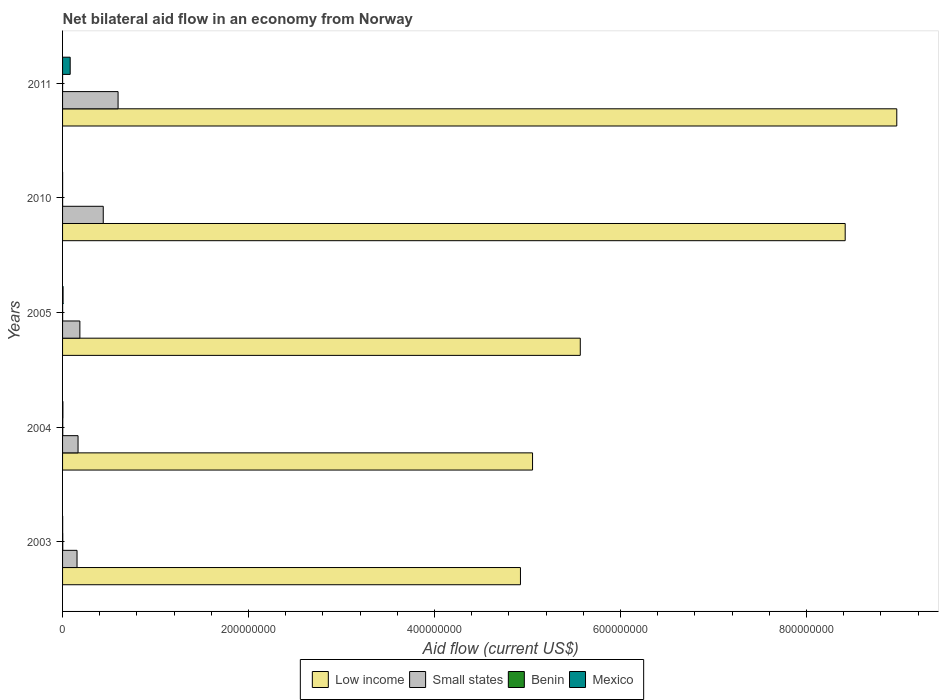Are the number of bars per tick equal to the number of legend labels?
Ensure brevity in your answer.  Yes. How many bars are there on the 3rd tick from the top?
Give a very brief answer. 4. How many bars are there on the 1st tick from the bottom?
Your answer should be very brief. 4. What is the label of the 3rd group of bars from the top?
Ensure brevity in your answer.  2005. In how many cases, is the number of bars for a given year not equal to the number of legend labels?
Offer a very short reply. 0. What is the net bilateral aid flow in Small states in 2003?
Make the answer very short. 1.56e+07. Across all years, what is the maximum net bilateral aid flow in Mexico?
Offer a terse response. 8.19e+06. Across all years, what is the minimum net bilateral aid flow in Mexico?
Offer a very short reply. 5.00e+04. What is the difference between the net bilateral aid flow in Small states in 2003 and that in 2004?
Offer a very short reply. -1.10e+06. What is the difference between the net bilateral aid flow in Low income in 2004 and the net bilateral aid flow in Benin in 2011?
Ensure brevity in your answer.  5.05e+08. What is the average net bilateral aid flow in Small states per year?
Offer a terse response. 3.09e+07. In the year 2010, what is the difference between the net bilateral aid flow in Low income and net bilateral aid flow in Mexico?
Keep it short and to the point. 8.42e+08. In how many years, is the net bilateral aid flow in Benin greater than 560000000 US$?
Offer a terse response. 0. Is the net bilateral aid flow in Mexico in 2003 less than that in 2010?
Keep it short and to the point. No. Is the difference between the net bilateral aid flow in Low income in 2003 and 2004 greater than the difference between the net bilateral aid flow in Mexico in 2003 and 2004?
Your answer should be very brief. No. What is the difference between the highest and the second highest net bilateral aid flow in Low income?
Offer a terse response. 5.55e+07. What is the difference between the highest and the lowest net bilateral aid flow in Mexico?
Give a very brief answer. 8.14e+06. What does the 2nd bar from the top in 2003 represents?
Give a very brief answer. Benin. What does the 3rd bar from the bottom in 2005 represents?
Your answer should be very brief. Benin. How many bars are there?
Make the answer very short. 20. What is the difference between two consecutive major ticks on the X-axis?
Make the answer very short. 2.00e+08. How many legend labels are there?
Provide a succinct answer. 4. How are the legend labels stacked?
Your answer should be compact. Horizontal. What is the title of the graph?
Give a very brief answer. Net bilateral aid flow in an economy from Norway. What is the Aid flow (current US$) in Low income in 2003?
Offer a terse response. 4.92e+08. What is the Aid flow (current US$) in Small states in 2003?
Your response must be concise. 1.56e+07. What is the Aid flow (current US$) of Low income in 2004?
Offer a terse response. 5.05e+08. What is the Aid flow (current US$) in Small states in 2004?
Your response must be concise. 1.66e+07. What is the Aid flow (current US$) in Mexico in 2004?
Ensure brevity in your answer.  3.60e+05. What is the Aid flow (current US$) in Low income in 2005?
Provide a short and direct response. 5.57e+08. What is the Aid flow (current US$) of Small states in 2005?
Give a very brief answer. 1.86e+07. What is the Aid flow (current US$) of Benin in 2005?
Provide a short and direct response. 6.00e+04. What is the Aid flow (current US$) in Mexico in 2005?
Ensure brevity in your answer.  5.30e+05. What is the Aid flow (current US$) of Low income in 2010?
Offer a very short reply. 8.42e+08. What is the Aid flow (current US$) of Small states in 2010?
Keep it short and to the point. 4.38e+07. What is the Aid flow (current US$) in Benin in 2010?
Your answer should be compact. 5.00e+04. What is the Aid flow (current US$) in Mexico in 2010?
Your answer should be compact. 5.00e+04. What is the Aid flow (current US$) in Low income in 2011?
Your answer should be very brief. 8.97e+08. What is the Aid flow (current US$) of Small states in 2011?
Your response must be concise. 5.97e+07. What is the Aid flow (current US$) of Mexico in 2011?
Provide a short and direct response. 8.19e+06. Across all years, what is the maximum Aid flow (current US$) in Low income?
Your response must be concise. 8.97e+08. Across all years, what is the maximum Aid flow (current US$) in Small states?
Make the answer very short. 5.97e+07. Across all years, what is the maximum Aid flow (current US$) of Benin?
Your answer should be compact. 2.20e+05. Across all years, what is the maximum Aid flow (current US$) of Mexico?
Provide a short and direct response. 8.19e+06. Across all years, what is the minimum Aid flow (current US$) of Low income?
Offer a very short reply. 4.92e+08. Across all years, what is the minimum Aid flow (current US$) in Small states?
Your response must be concise. 1.56e+07. Across all years, what is the minimum Aid flow (current US$) of Benin?
Offer a very short reply. 10000. What is the total Aid flow (current US$) of Low income in the graph?
Your response must be concise. 3.29e+09. What is the total Aid flow (current US$) in Small states in the graph?
Provide a short and direct response. 1.54e+08. What is the total Aid flow (current US$) in Benin in the graph?
Provide a succinct answer. 5.50e+05. What is the total Aid flow (current US$) in Mexico in the graph?
Keep it short and to the point. 9.22e+06. What is the difference between the Aid flow (current US$) of Low income in 2003 and that in 2004?
Ensure brevity in your answer.  -1.30e+07. What is the difference between the Aid flow (current US$) in Small states in 2003 and that in 2004?
Your answer should be very brief. -1.10e+06. What is the difference between the Aid flow (current US$) in Benin in 2003 and that in 2004?
Offer a terse response. -10000. What is the difference between the Aid flow (current US$) of Mexico in 2003 and that in 2004?
Make the answer very short. -2.70e+05. What is the difference between the Aid flow (current US$) in Low income in 2003 and that in 2005?
Provide a short and direct response. -6.43e+07. What is the difference between the Aid flow (current US$) of Small states in 2003 and that in 2005?
Offer a terse response. -3.07e+06. What is the difference between the Aid flow (current US$) in Benin in 2003 and that in 2005?
Provide a succinct answer. 1.50e+05. What is the difference between the Aid flow (current US$) in Mexico in 2003 and that in 2005?
Provide a short and direct response. -4.40e+05. What is the difference between the Aid flow (current US$) in Low income in 2003 and that in 2010?
Your answer should be compact. -3.49e+08. What is the difference between the Aid flow (current US$) of Small states in 2003 and that in 2010?
Your response must be concise. -2.82e+07. What is the difference between the Aid flow (current US$) in Low income in 2003 and that in 2011?
Your answer should be compact. -4.05e+08. What is the difference between the Aid flow (current US$) of Small states in 2003 and that in 2011?
Keep it short and to the point. -4.42e+07. What is the difference between the Aid flow (current US$) in Benin in 2003 and that in 2011?
Give a very brief answer. 2.00e+05. What is the difference between the Aid flow (current US$) in Mexico in 2003 and that in 2011?
Make the answer very short. -8.10e+06. What is the difference between the Aid flow (current US$) of Low income in 2004 and that in 2005?
Provide a succinct answer. -5.13e+07. What is the difference between the Aid flow (current US$) in Small states in 2004 and that in 2005?
Your answer should be compact. -1.97e+06. What is the difference between the Aid flow (current US$) in Benin in 2004 and that in 2005?
Offer a very short reply. 1.60e+05. What is the difference between the Aid flow (current US$) of Low income in 2004 and that in 2010?
Provide a short and direct response. -3.36e+08. What is the difference between the Aid flow (current US$) in Small states in 2004 and that in 2010?
Your response must be concise. -2.71e+07. What is the difference between the Aid flow (current US$) in Low income in 2004 and that in 2011?
Make the answer very short. -3.92e+08. What is the difference between the Aid flow (current US$) of Small states in 2004 and that in 2011?
Provide a short and direct response. -4.30e+07. What is the difference between the Aid flow (current US$) in Mexico in 2004 and that in 2011?
Ensure brevity in your answer.  -7.83e+06. What is the difference between the Aid flow (current US$) in Low income in 2005 and that in 2010?
Make the answer very short. -2.85e+08. What is the difference between the Aid flow (current US$) of Small states in 2005 and that in 2010?
Offer a terse response. -2.51e+07. What is the difference between the Aid flow (current US$) in Benin in 2005 and that in 2010?
Your answer should be compact. 10000. What is the difference between the Aid flow (current US$) in Low income in 2005 and that in 2011?
Your response must be concise. -3.40e+08. What is the difference between the Aid flow (current US$) in Small states in 2005 and that in 2011?
Offer a very short reply. -4.11e+07. What is the difference between the Aid flow (current US$) of Benin in 2005 and that in 2011?
Make the answer very short. 5.00e+04. What is the difference between the Aid flow (current US$) in Mexico in 2005 and that in 2011?
Your answer should be very brief. -7.66e+06. What is the difference between the Aid flow (current US$) of Low income in 2010 and that in 2011?
Ensure brevity in your answer.  -5.55e+07. What is the difference between the Aid flow (current US$) in Small states in 2010 and that in 2011?
Offer a very short reply. -1.59e+07. What is the difference between the Aid flow (current US$) of Mexico in 2010 and that in 2011?
Offer a terse response. -8.14e+06. What is the difference between the Aid flow (current US$) of Low income in 2003 and the Aid flow (current US$) of Small states in 2004?
Provide a short and direct response. 4.76e+08. What is the difference between the Aid flow (current US$) of Low income in 2003 and the Aid flow (current US$) of Benin in 2004?
Offer a terse response. 4.92e+08. What is the difference between the Aid flow (current US$) in Low income in 2003 and the Aid flow (current US$) in Mexico in 2004?
Keep it short and to the point. 4.92e+08. What is the difference between the Aid flow (current US$) of Small states in 2003 and the Aid flow (current US$) of Benin in 2004?
Give a very brief answer. 1.53e+07. What is the difference between the Aid flow (current US$) in Small states in 2003 and the Aid flow (current US$) in Mexico in 2004?
Your response must be concise. 1.52e+07. What is the difference between the Aid flow (current US$) of Benin in 2003 and the Aid flow (current US$) of Mexico in 2004?
Your answer should be very brief. -1.50e+05. What is the difference between the Aid flow (current US$) of Low income in 2003 and the Aid flow (current US$) of Small states in 2005?
Offer a terse response. 4.74e+08. What is the difference between the Aid flow (current US$) in Low income in 2003 and the Aid flow (current US$) in Benin in 2005?
Provide a succinct answer. 4.92e+08. What is the difference between the Aid flow (current US$) of Low income in 2003 and the Aid flow (current US$) of Mexico in 2005?
Your response must be concise. 4.92e+08. What is the difference between the Aid flow (current US$) in Small states in 2003 and the Aid flow (current US$) in Benin in 2005?
Keep it short and to the point. 1.55e+07. What is the difference between the Aid flow (current US$) of Small states in 2003 and the Aid flow (current US$) of Mexico in 2005?
Keep it short and to the point. 1.50e+07. What is the difference between the Aid flow (current US$) of Benin in 2003 and the Aid flow (current US$) of Mexico in 2005?
Offer a very short reply. -3.20e+05. What is the difference between the Aid flow (current US$) in Low income in 2003 and the Aid flow (current US$) in Small states in 2010?
Your response must be concise. 4.49e+08. What is the difference between the Aid flow (current US$) of Low income in 2003 and the Aid flow (current US$) of Benin in 2010?
Provide a short and direct response. 4.92e+08. What is the difference between the Aid flow (current US$) in Low income in 2003 and the Aid flow (current US$) in Mexico in 2010?
Provide a succinct answer. 4.92e+08. What is the difference between the Aid flow (current US$) in Small states in 2003 and the Aid flow (current US$) in Benin in 2010?
Ensure brevity in your answer.  1.55e+07. What is the difference between the Aid flow (current US$) in Small states in 2003 and the Aid flow (current US$) in Mexico in 2010?
Your answer should be compact. 1.55e+07. What is the difference between the Aid flow (current US$) in Low income in 2003 and the Aid flow (current US$) in Small states in 2011?
Offer a very short reply. 4.33e+08. What is the difference between the Aid flow (current US$) in Low income in 2003 and the Aid flow (current US$) in Benin in 2011?
Offer a terse response. 4.92e+08. What is the difference between the Aid flow (current US$) in Low income in 2003 and the Aid flow (current US$) in Mexico in 2011?
Your answer should be very brief. 4.84e+08. What is the difference between the Aid flow (current US$) of Small states in 2003 and the Aid flow (current US$) of Benin in 2011?
Your answer should be very brief. 1.55e+07. What is the difference between the Aid flow (current US$) of Small states in 2003 and the Aid flow (current US$) of Mexico in 2011?
Provide a succinct answer. 7.36e+06. What is the difference between the Aid flow (current US$) in Benin in 2003 and the Aid flow (current US$) in Mexico in 2011?
Provide a succinct answer. -7.98e+06. What is the difference between the Aid flow (current US$) of Low income in 2004 and the Aid flow (current US$) of Small states in 2005?
Offer a very short reply. 4.87e+08. What is the difference between the Aid flow (current US$) of Low income in 2004 and the Aid flow (current US$) of Benin in 2005?
Your answer should be compact. 5.05e+08. What is the difference between the Aid flow (current US$) in Low income in 2004 and the Aid flow (current US$) in Mexico in 2005?
Give a very brief answer. 5.05e+08. What is the difference between the Aid flow (current US$) in Small states in 2004 and the Aid flow (current US$) in Benin in 2005?
Offer a terse response. 1.66e+07. What is the difference between the Aid flow (current US$) of Small states in 2004 and the Aid flow (current US$) of Mexico in 2005?
Offer a terse response. 1.61e+07. What is the difference between the Aid flow (current US$) in Benin in 2004 and the Aid flow (current US$) in Mexico in 2005?
Your answer should be compact. -3.10e+05. What is the difference between the Aid flow (current US$) in Low income in 2004 and the Aid flow (current US$) in Small states in 2010?
Keep it short and to the point. 4.62e+08. What is the difference between the Aid flow (current US$) of Low income in 2004 and the Aid flow (current US$) of Benin in 2010?
Offer a terse response. 5.05e+08. What is the difference between the Aid flow (current US$) in Low income in 2004 and the Aid flow (current US$) in Mexico in 2010?
Offer a very short reply. 5.05e+08. What is the difference between the Aid flow (current US$) of Small states in 2004 and the Aid flow (current US$) of Benin in 2010?
Your answer should be very brief. 1.66e+07. What is the difference between the Aid flow (current US$) in Small states in 2004 and the Aid flow (current US$) in Mexico in 2010?
Give a very brief answer. 1.66e+07. What is the difference between the Aid flow (current US$) of Low income in 2004 and the Aid flow (current US$) of Small states in 2011?
Your answer should be very brief. 4.46e+08. What is the difference between the Aid flow (current US$) of Low income in 2004 and the Aid flow (current US$) of Benin in 2011?
Make the answer very short. 5.05e+08. What is the difference between the Aid flow (current US$) of Low income in 2004 and the Aid flow (current US$) of Mexico in 2011?
Keep it short and to the point. 4.97e+08. What is the difference between the Aid flow (current US$) in Small states in 2004 and the Aid flow (current US$) in Benin in 2011?
Offer a very short reply. 1.66e+07. What is the difference between the Aid flow (current US$) in Small states in 2004 and the Aid flow (current US$) in Mexico in 2011?
Your answer should be very brief. 8.46e+06. What is the difference between the Aid flow (current US$) in Benin in 2004 and the Aid flow (current US$) in Mexico in 2011?
Offer a very short reply. -7.97e+06. What is the difference between the Aid flow (current US$) of Low income in 2005 and the Aid flow (current US$) of Small states in 2010?
Make the answer very short. 5.13e+08. What is the difference between the Aid flow (current US$) of Low income in 2005 and the Aid flow (current US$) of Benin in 2010?
Keep it short and to the point. 5.57e+08. What is the difference between the Aid flow (current US$) in Low income in 2005 and the Aid flow (current US$) in Mexico in 2010?
Your response must be concise. 5.57e+08. What is the difference between the Aid flow (current US$) of Small states in 2005 and the Aid flow (current US$) of Benin in 2010?
Keep it short and to the point. 1.86e+07. What is the difference between the Aid flow (current US$) of Small states in 2005 and the Aid flow (current US$) of Mexico in 2010?
Keep it short and to the point. 1.86e+07. What is the difference between the Aid flow (current US$) in Low income in 2005 and the Aid flow (current US$) in Small states in 2011?
Your answer should be very brief. 4.97e+08. What is the difference between the Aid flow (current US$) of Low income in 2005 and the Aid flow (current US$) of Benin in 2011?
Ensure brevity in your answer.  5.57e+08. What is the difference between the Aid flow (current US$) in Low income in 2005 and the Aid flow (current US$) in Mexico in 2011?
Keep it short and to the point. 5.49e+08. What is the difference between the Aid flow (current US$) of Small states in 2005 and the Aid flow (current US$) of Benin in 2011?
Keep it short and to the point. 1.86e+07. What is the difference between the Aid flow (current US$) of Small states in 2005 and the Aid flow (current US$) of Mexico in 2011?
Give a very brief answer. 1.04e+07. What is the difference between the Aid flow (current US$) in Benin in 2005 and the Aid flow (current US$) in Mexico in 2011?
Offer a very short reply. -8.13e+06. What is the difference between the Aid flow (current US$) in Low income in 2010 and the Aid flow (current US$) in Small states in 2011?
Offer a terse response. 7.82e+08. What is the difference between the Aid flow (current US$) of Low income in 2010 and the Aid flow (current US$) of Benin in 2011?
Your response must be concise. 8.42e+08. What is the difference between the Aid flow (current US$) in Low income in 2010 and the Aid flow (current US$) in Mexico in 2011?
Keep it short and to the point. 8.34e+08. What is the difference between the Aid flow (current US$) in Small states in 2010 and the Aid flow (current US$) in Benin in 2011?
Ensure brevity in your answer.  4.38e+07. What is the difference between the Aid flow (current US$) of Small states in 2010 and the Aid flow (current US$) of Mexico in 2011?
Keep it short and to the point. 3.56e+07. What is the difference between the Aid flow (current US$) of Benin in 2010 and the Aid flow (current US$) of Mexico in 2011?
Your answer should be very brief. -8.14e+06. What is the average Aid flow (current US$) in Low income per year?
Offer a very short reply. 6.59e+08. What is the average Aid flow (current US$) in Small states per year?
Provide a succinct answer. 3.09e+07. What is the average Aid flow (current US$) of Benin per year?
Offer a very short reply. 1.10e+05. What is the average Aid flow (current US$) in Mexico per year?
Keep it short and to the point. 1.84e+06. In the year 2003, what is the difference between the Aid flow (current US$) in Low income and Aid flow (current US$) in Small states?
Ensure brevity in your answer.  4.77e+08. In the year 2003, what is the difference between the Aid flow (current US$) in Low income and Aid flow (current US$) in Benin?
Offer a terse response. 4.92e+08. In the year 2003, what is the difference between the Aid flow (current US$) in Low income and Aid flow (current US$) in Mexico?
Ensure brevity in your answer.  4.92e+08. In the year 2003, what is the difference between the Aid flow (current US$) of Small states and Aid flow (current US$) of Benin?
Your response must be concise. 1.53e+07. In the year 2003, what is the difference between the Aid flow (current US$) in Small states and Aid flow (current US$) in Mexico?
Offer a very short reply. 1.55e+07. In the year 2004, what is the difference between the Aid flow (current US$) of Low income and Aid flow (current US$) of Small states?
Make the answer very short. 4.89e+08. In the year 2004, what is the difference between the Aid flow (current US$) of Low income and Aid flow (current US$) of Benin?
Make the answer very short. 5.05e+08. In the year 2004, what is the difference between the Aid flow (current US$) of Low income and Aid flow (current US$) of Mexico?
Give a very brief answer. 5.05e+08. In the year 2004, what is the difference between the Aid flow (current US$) of Small states and Aid flow (current US$) of Benin?
Offer a very short reply. 1.64e+07. In the year 2004, what is the difference between the Aid flow (current US$) in Small states and Aid flow (current US$) in Mexico?
Offer a very short reply. 1.63e+07. In the year 2004, what is the difference between the Aid flow (current US$) of Benin and Aid flow (current US$) of Mexico?
Give a very brief answer. -1.40e+05. In the year 2005, what is the difference between the Aid flow (current US$) of Low income and Aid flow (current US$) of Small states?
Offer a terse response. 5.38e+08. In the year 2005, what is the difference between the Aid flow (current US$) of Low income and Aid flow (current US$) of Benin?
Your answer should be very brief. 5.57e+08. In the year 2005, what is the difference between the Aid flow (current US$) of Low income and Aid flow (current US$) of Mexico?
Give a very brief answer. 5.56e+08. In the year 2005, what is the difference between the Aid flow (current US$) in Small states and Aid flow (current US$) in Benin?
Make the answer very short. 1.86e+07. In the year 2005, what is the difference between the Aid flow (current US$) of Small states and Aid flow (current US$) of Mexico?
Your answer should be very brief. 1.81e+07. In the year 2005, what is the difference between the Aid flow (current US$) in Benin and Aid flow (current US$) in Mexico?
Keep it short and to the point. -4.70e+05. In the year 2010, what is the difference between the Aid flow (current US$) of Low income and Aid flow (current US$) of Small states?
Your answer should be very brief. 7.98e+08. In the year 2010, what is the difference between the Aid flow (current US$) of Low income and Aid flow (current US$) of Benin?
Provide a short and direct response. 8.42e+08. In the year 2010, what is the difference between the Aid flow (current US$) in Low income and Aid flow (current US$) in Mexico?
Make the answer very short. 8.42e+08. In the year 2010, what is the difference between the Aid flow (current US$) of Small states and Aid flow (current US$) of Benin?
Ensure brevity in your answer.  4.37e+07. In the year 2010, what is the difference between the Aid flow (current US$) in Small states and Aid flow (current US$) in Mexico?
Offer a very short reply. 4.37e+07. In the year 2010, what is the difference between the Aid flow (current US$) of Benin and Aid flow (current US$) of Mexico?
Keep it short and to the point. 0. In the year 2011, what is the difference between the Aid flow (current US$) of Low income and Aid flow (current US$) of Small states?
Provide a short and direct response. 8.37e+08. In the year 2011, what is the difference between the Aid flow (current US$) of Low income and Aid flow (current US$) of Benin?
Offer a very short reply. 8.97e+08. In the year 2011, what is the difference between the Aid flow (current US$) of Low income and Aid flow (current US$) of Mexico?
Keep it short and to the point. 8.89e+08. In the year 2011, what is the difference between the Aid flow (current US$) of Small states and Aid flow (current US$) of Benin?
Make the answer very short. 5.97e+07. In the year 2011, what is the difference between the Aid flow (current US$) of Small states and Aid flow (current US$) of Mexico?
Offer a very short reply. 5.15e+07. In the year 2011, what is the difference between the Aid flow (current US$) in Benin and Aid flow (current US$) in Mexico?
Your response must be concise. -8.18e+06. What is the ratio of the Aid flow (current US$) in Low income in 2003 to that in 2004?
Provide a short and direct response. 0.97. What is the ratio of the Aid flow (current US$) in Small states in 2003 to that in 2004?
Provide a succinct answer. 0.93. What is the ratio of the Aid flow (current US$) in Benin in 2003 to that in 2004?
Provide a short and direct response. 0.95. What is the ratio of the Aid flow (current US$) in Mexico in 2003 to that in 2004?
Your answer should be compact. 0.25. What is the ratio of the Aid flow (current US$) in Low income in 2003 to that in 2005?
Give a very brief answer. 0.88. What is the ratio of the Aid flow (current US$) in Small states in 2003 to that in 2005?
Your answer should be very brief. 0.84. What is the ratio of the Aid flow (current US$) of Mexico in 2003 to that in 2005?
Make the answer very short. 0.17. What is the ratio of the Aid flow (current US$) in Low income in 2003 to that in 2010?
Provide a short and direct response. 0.59. What is the ratio of the Aid flow (current US$) in Small states in 2003 to that in 2010?
Your answer should be compact. 0.36. What is the ratio of the Aid flow (current US$) in Benin in 2003 to that in 2010?
Offer a very short reply. 4.2. What is the ratio of the Aid flow (current US$) in Mexico in 2003 to that in 2010?
Provide a succinct answer. 1.8. What is the ratio of the Aid flow (current US$) of Low income in 2003 to that in 2011?
Ensure brevity in your answer.  0.55. What is the ratio of the Aid flow (current US$) in Small states in 2003 to that in 2011?
Your response must be concise. 0.26. What is the ratio of the Aid flow (current US$) in Mexico in 2003 to that in 2011?
Ensure brevity in your answer.  0.01. What is the ratio of the Aid flow (current US$) in Low income in 2004 to that in 2005?
Provide a short and direct response. 0.91. What is the ratio of the Aid flow (current US$) in Small states in 2004 to that in 2005?
Provide a short and direct response. 0.89. What is the ratio of the Aid flow (current US$) of Benin in 2004 to that in 2005?
Keep it short and to the point. 3.67. What is the ratio of the Aid flow (current US$) in Mexico in 2004 to that in 2005?
Give a very brief answer. 0.68. What is the ratio of the Aid flow (current US$) in Low income in 2004 to that in 2010?
Offer a very short reply. 0.6. What is the ratio of the Aid flow (current US$) in Small states in 2004 to that in 2010?
Ensure brevity in your answer.  0.38. What is the ratio of the Aid flow (current US$) of Low income in 2004 to that in 2011?
Your response must be concise. 0.56. What is the ratio of the Aid flow (current US$) of Small states in 2004 to that in 2011?
Your answer should be very brief. 0.28. What is the ratio of the Aid flow (current US$) in Mexico in 2004 to that in 2011?
Give a very brief answer. 0.04. What is the ratio of the Aid flow (current US$) of Low income in 2005 to that in 2010?
Your response must be concise. 0.66. What is the ratio of the Aid flow (current US$) in Small states in 2005 to that in 2010?
Your response must be concise. 0.43. What is the ratio of the Aid flow (current US$) of Low income in 2005 to that in 2011?
Keep it short and to the point. 0.62. What is the ratio of the Aid flow (current US$) in Small states in 2005 to that in 2011?
Provide a short and direct response. 0.31. What is the ratio of the Aid flow (current US$) of Mexico in 2005 to that in 2011?
Your response must be concise. 0.06. What is the ratio of the Aid flow (current US$) in Low income in 2010 to that in 2011?
Give a very brief answer. 0.94. What is the ratio of the Aid flow (current US$) of Small states in 2010 to that in 2011?
Make the answer very short. 0.73. What is the ratio of the Aid flow (current US$) of Mexico in 2010 to that in 2011?
Your answer should be very brief. 0.01. What is the difference between the highest and the second highest Aid flow (current US$) of Low income?
Provide a short and direct response. 5.55e+07. What is the difference between the highest and the second highest Aid flow (current US$) of Small states?
Offer a terse response. 1.59e+07. What is the difference between the highest and the second highest Aid flow (current US$) of Benin?
Keep it short and to the point. 10000. What is the difference between the highest and the second highest Aid flow (current US$) in Mexico?
Keep it short and to the point. 7.66e+06. What is the difference between the highest and the lowest Aid flow (current US$) of Low income?
Provide a succinct answer. 4.05e+08. What is the difference between the highest and the lowest Aid flow (current US$) of Small states?
Offer a very short reply. 4.42e+07. What is the difference between the highest and the lowest Aid flow (current US$) in Mexico?
Make the answer very short. 8.14e+06. 